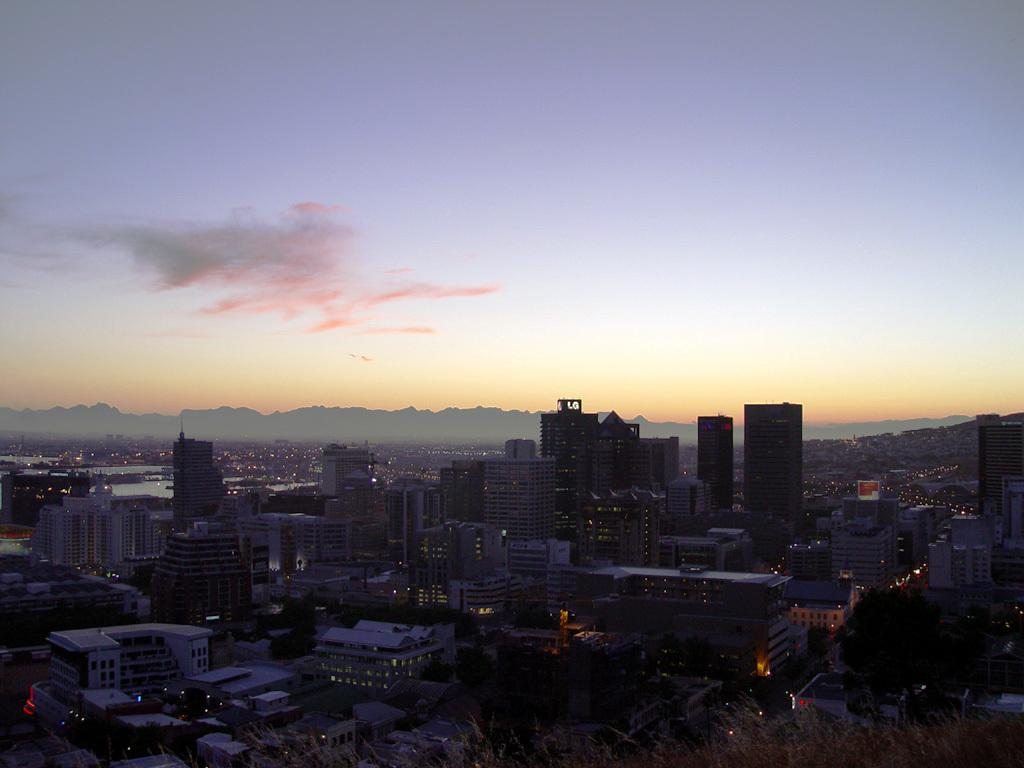What type of landscape is depicted in the image? The image shows a view of the city. What structures can be seen in the cityscape? There are buildings and skyscrapers in the image. Are there any natural elements present in the image? Yes, there are trees in the image. What is the condition of the sky in the image? The sky in the image has clouds. How many quince are present in the image? There are no quince present in the image. What type of books can be seen on the shelves in the image? There are no bookshelves or books present in the image. 